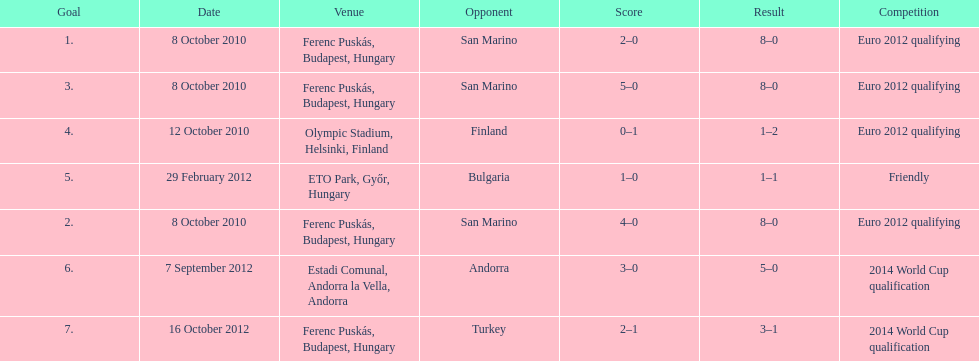Szalai scored only one more international goal against all other countries put together than he did against what one country? San Marino. 